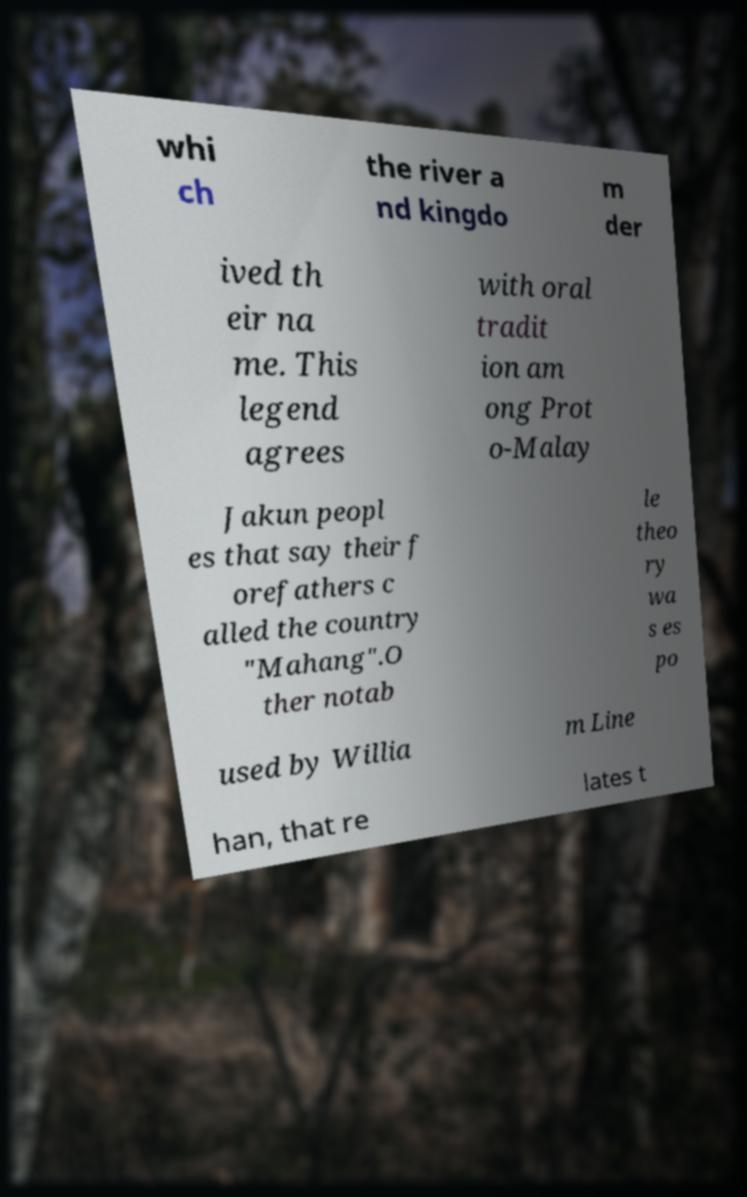Please read and relay the text visible in this image. What does it say? whi ch the river a nd kingdo m der ived th eir na me. This legend agrees with oral tradit ion am ong Prot o-Malay Jakun peopl es that say their f orefathers c alled the country "Mahang".O ther notab le theo ry wa s es po used by Willia m Line han, that re lates t 